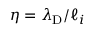Convert formula to latex. <formula><loc_0><loc_0><loc_500><loc_500>\eta = \lambda _ { D } / \ell _ { i }</formula> 